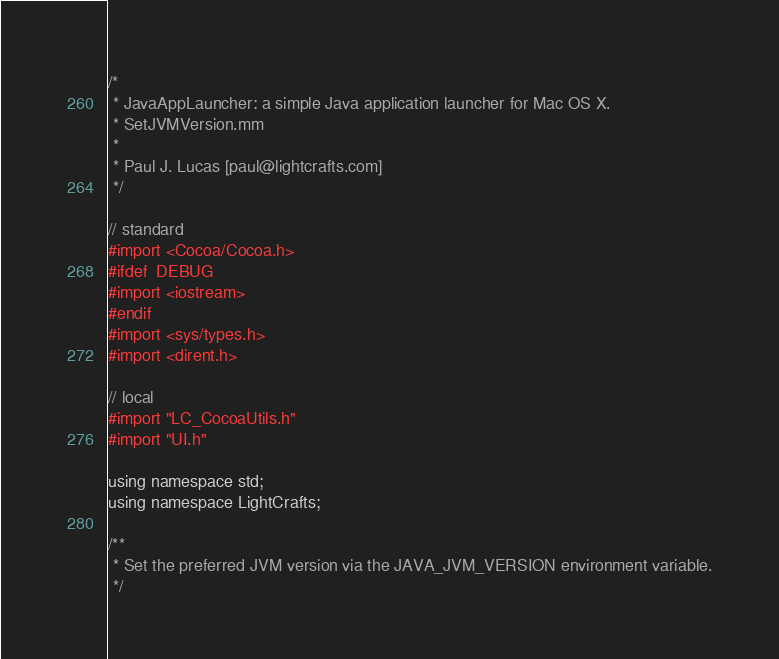<code> <loc_0><loc_0><loc_500><loc_500><_ObjectiveC_>/*
 * JavaAppLauncher: a simple Java application launcher for Mac OS X.
 * SetJVMVersion.mm
 *
 * Paul J. Lucas [paul@lightcrafts.com]
 */

// standard
#import <Cocoa/Cocoa.h>
#ifdef  DEBUG
#import <iostream>
#endif
#import <sys/types.h>
#import <dirent.h>

// local
#import "LC_CocoaUtils.h"
#import "UI.h"

using namespace std;
using namespace LightCrafts;

/**
 * Set the preferred JVM version via the JAVA_JVM_VERSION environment variable.
 */</code> 